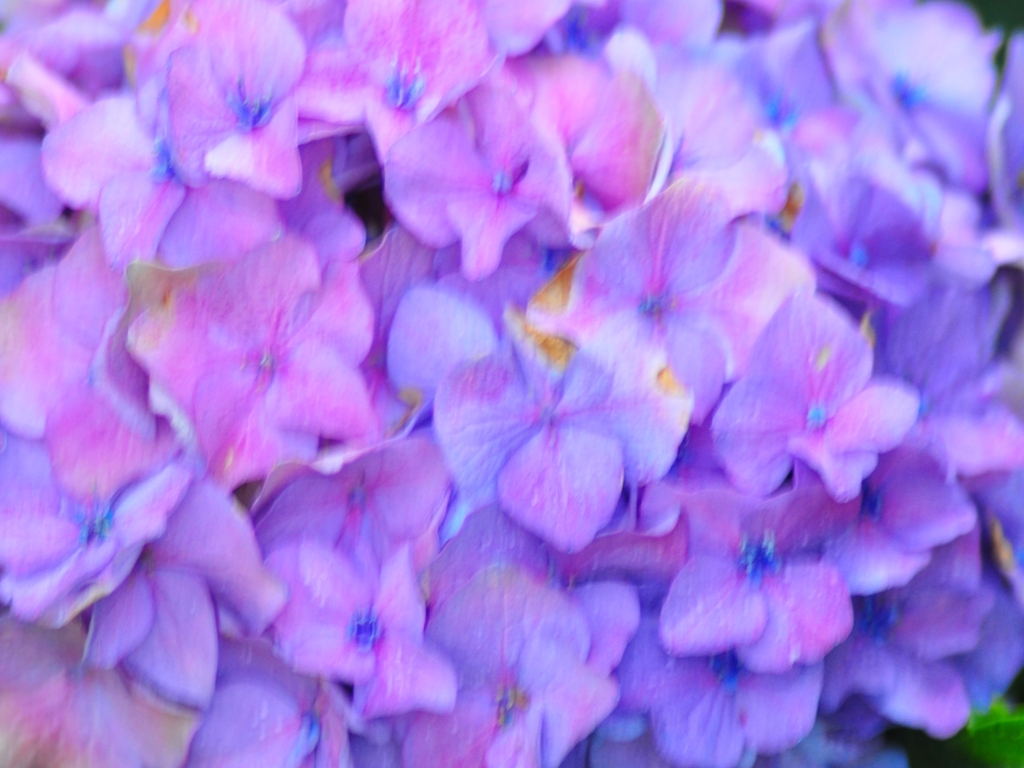How might these flowers be used in a garden or landscaping? Hydrangeas are popular in gardens for creating borders or as centerpiece shrubs due to their voluminous and colorful flower heads. They can also be planted in pots for patios or arranged in cut flower bouquets to bring their aesthetic indoors. 